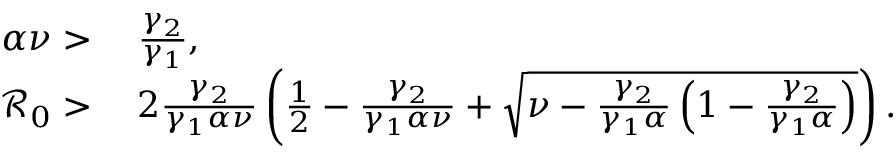<formula> <loc_0><loc_0><loc_500><loc_500>\begin{array} { r l } { \alpha \nu > } & { \, \frac { \gamma _ { 2 } } { \gamma _ { 1 } } , } \\ { \mathcal { R } _ { 0 } > } & { \, 2 \frac { \gamma _ { 2 } } { \gamma _ { 1 } \alpha \nu } \left ( \frac { 1 } { 2 } - \frac { \gamma _ { 2 } } { \gamma _ { 1 } \alpha \nu } + \sqrt { \nu - \frac { \gamma _ { 2 } } { \gamma _ { 1 } \alpha } \left ( 1 - \frac { \gamma _ { 2 } } { \gamma _ { 1 } \alpha } \right ) } \right ) . } \end{array}</formula> 